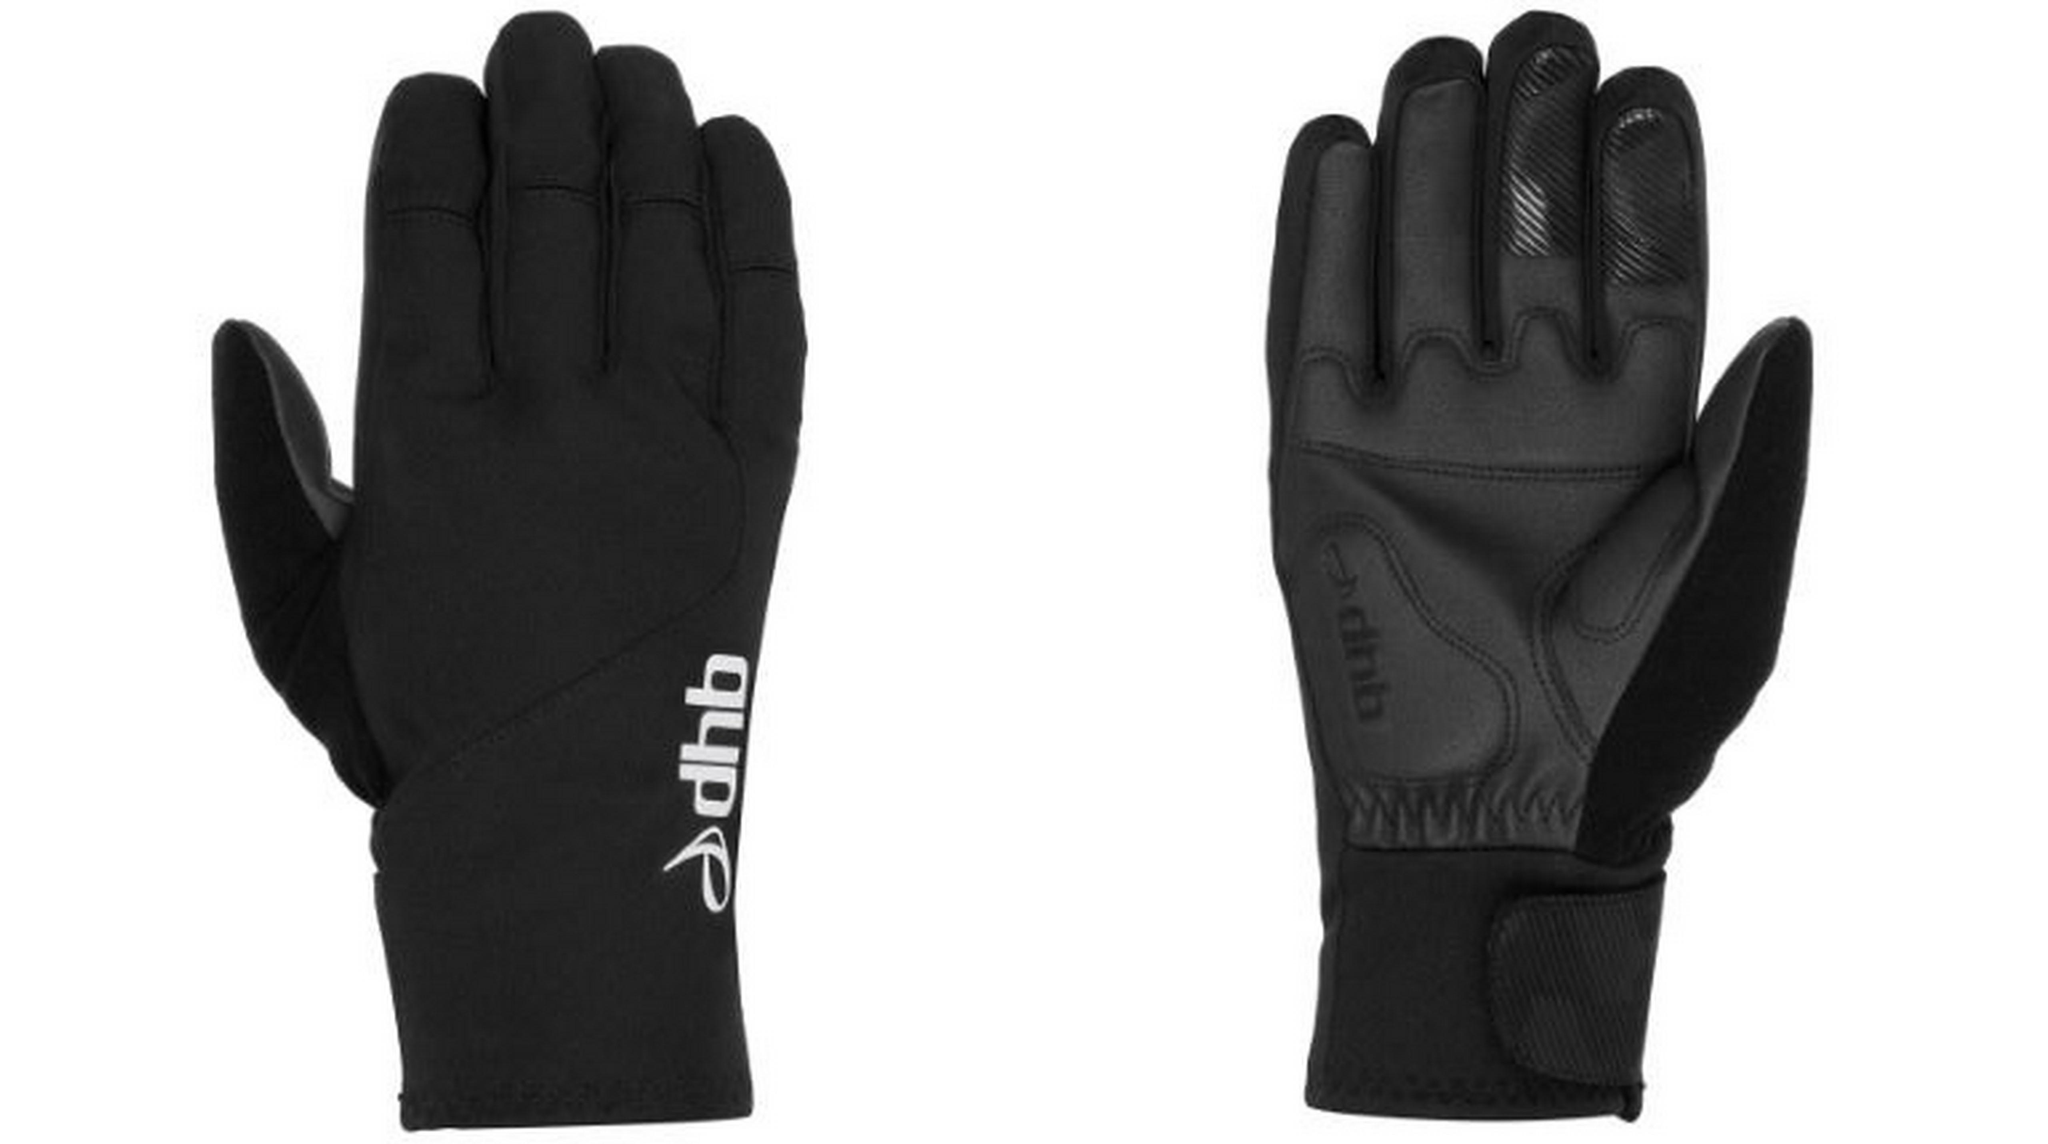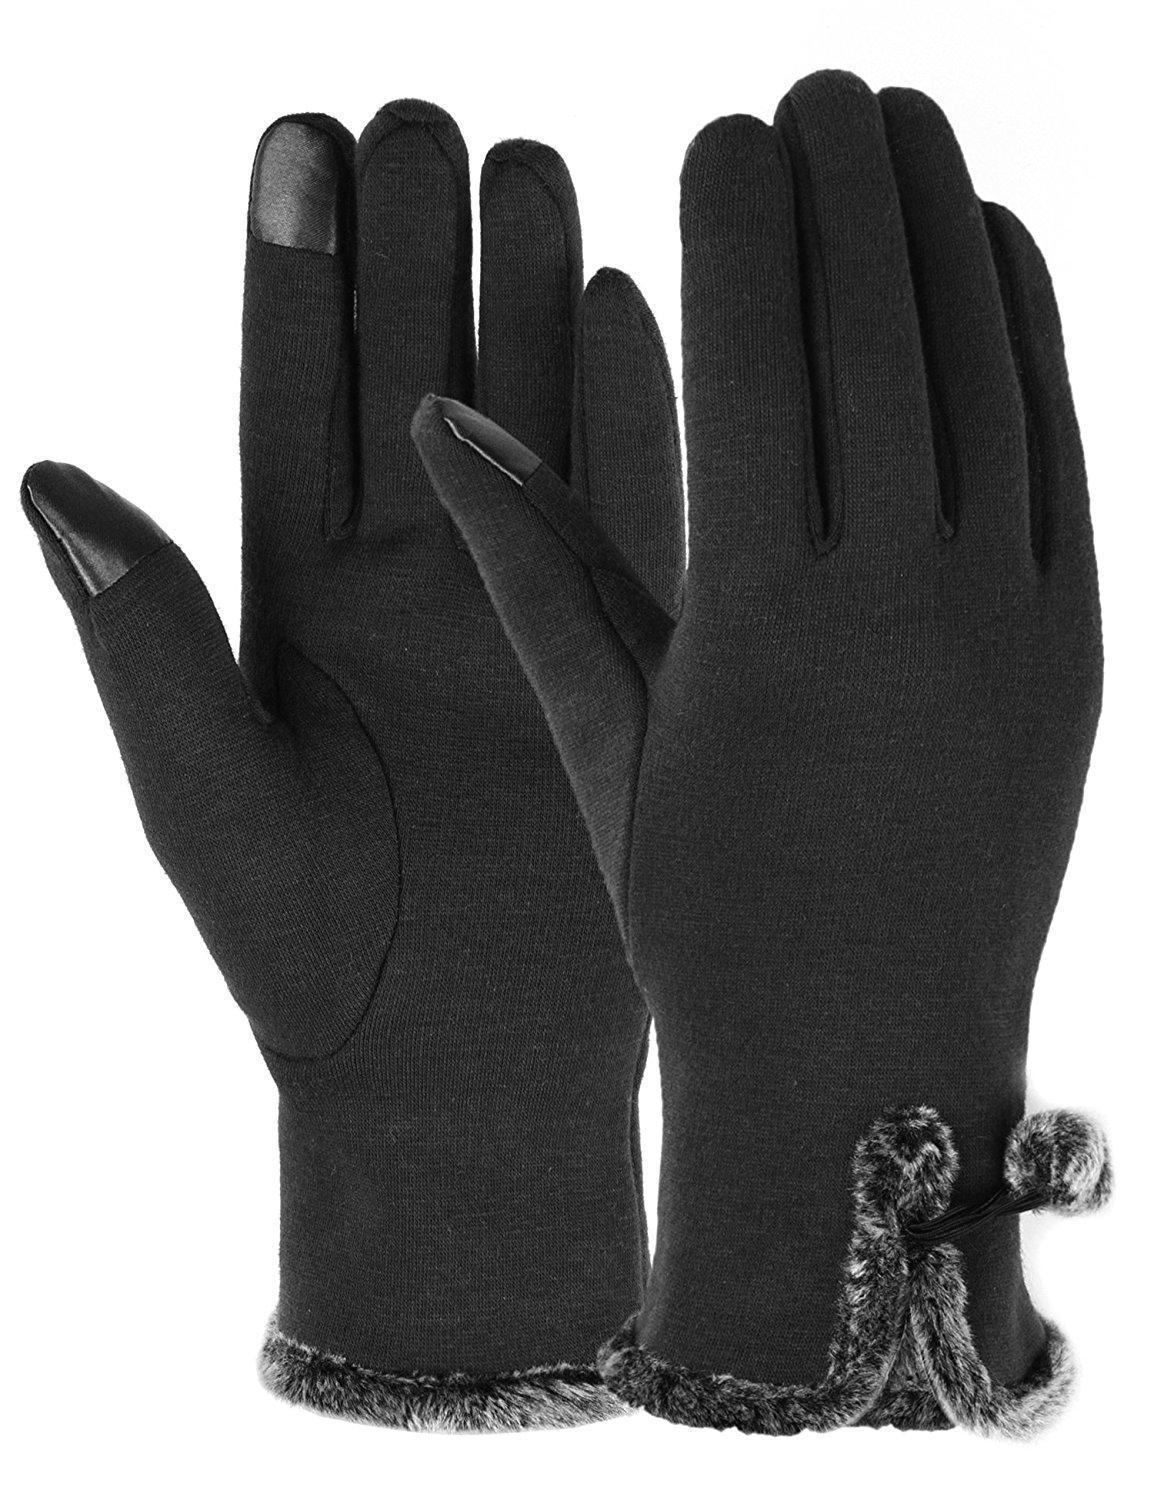The first image is the image on the left, the second image is the image on the right. Evaluate the accuracy of this statement regarding the images: "One image includes at least one pair of half-finger gloves with a mitten flap, and the other image shows one pair of knit mittens with fur cuffs at the wrists.". Is it true? Answer yes or no. No. The first image is the image on the left, the second image is the image on the right. Evaluate the accuracy of this statement regarding the images: "Only one of the images shows convertible mittens.". Is it true? Answer yes or no. No. 